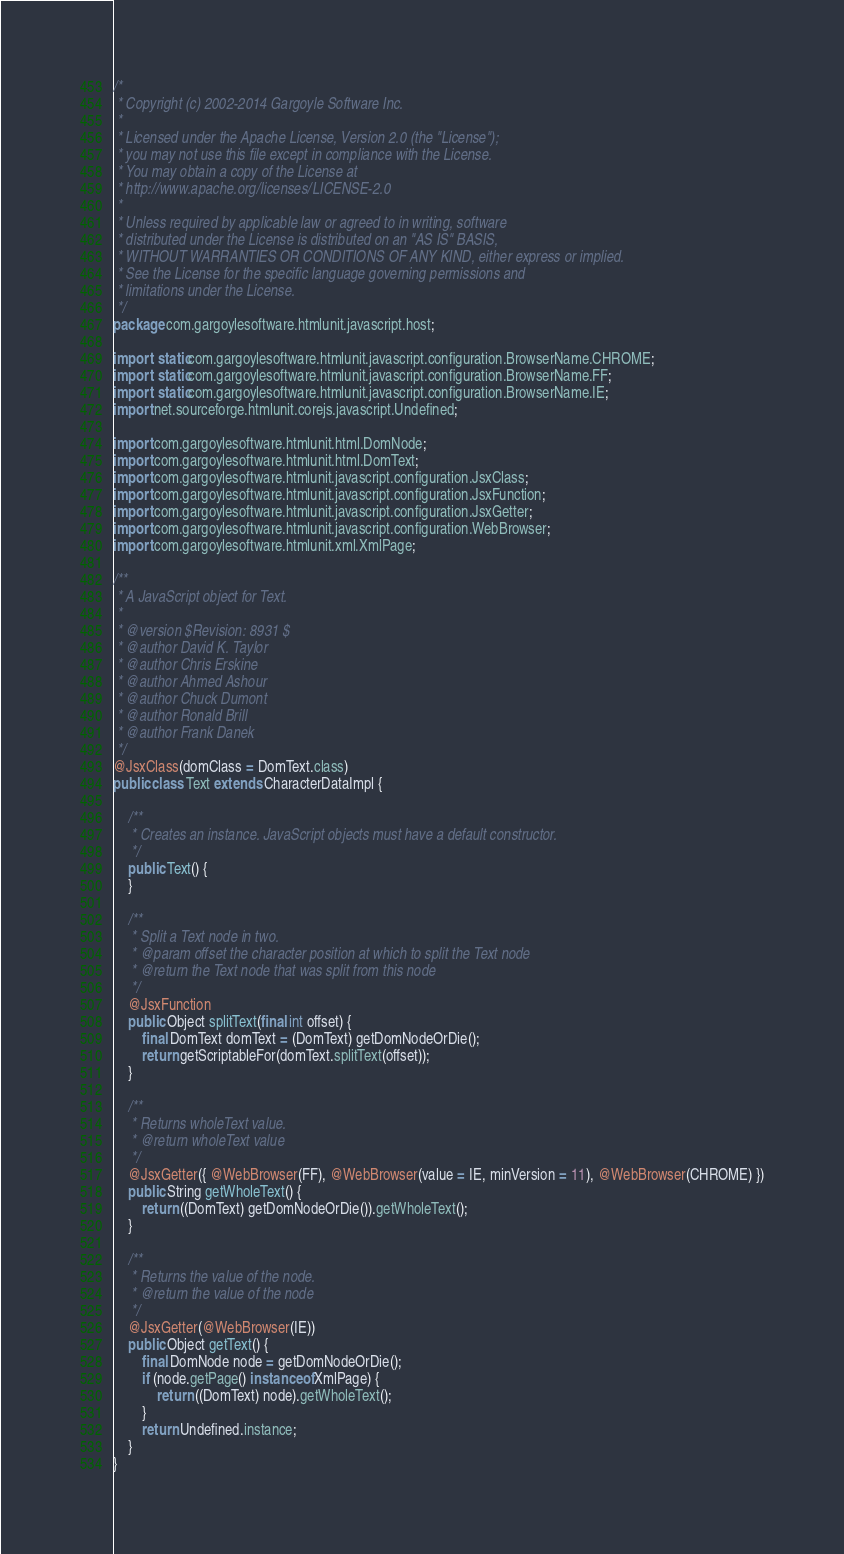Convert code to text. <code><loc_0><loc_0><loc_500><loc_500><_Java_>/*
 * Copyright (c) 2002-2014 Gargoyle Software Inc.
 *
 * Licensed under the Apache License, Version 2.0 (the "License");
 * you may not use this file except in compliance with the License.
 * You may obtain a copy of the License at
 * http://www.apache.org/licenses/LICENSE-2.0
 *
 * Unless required by applicable law or agreed to in writing, software
 * distributed under the License is distributed on an "AS IS" BASIS,
 * WITHOUT WARRANTIES OR CONDITIONS OF ANY KIND, either express or implied.
 * See the License for the specific language governing permissions and
 * limitations under the License.
 */
package com.gargoylesoftware.htmlunit.javascript.host;

import static com.gargoylesoftware.htmlunit.javascript.configuration.BrowserName.CHROME;
import static com.gargoylesoftware.htmlunit.javascript.configuration.BrowserName.FF;
import static com.gargoylesoftware.htmlunit.javascript.configuration.BrowserName.IE;
import net.sourceforge.htmlunit.corejs.javascript.Undefined;

import com.gargoylesoftware.htmlunit.html.DomNode;
import com.gargoylesoftware.htmlunit.html.DomText;
import com.gargoylesoftware.htmlunit.javascript.configuration.JsxClass;
import com.gargoylesoftware.htmlunit.javascript.configuration.JsxFunction;
import com.gargoylesoftware.htmlunit.javascript.configuration.JsxGetter;
import com.gargoylesoftware.htmlunit.javascript.configuration.WebBrowser;
import com.gargoylesoftware.htmlunit.xml.XmlPage;

/**
 * A JavaScript object for Text.
 *
 * @version $Revision: 8931 $
 * @author David K. Taylor
 * @author Chris Erskine
 * @author Ahmed Ashour
 * @author Chuck Dumont
 * @author Ronald Brill
 * @author Frank Danek
 */
@JsxClass(domClass = DomText.class)
public class Text extends CharacterDataImpl {

    /**
     * Creates an instance. JavaScript objects must have a default constructor.
     */
    public Text() {
    }

    /**
     * Split a Text node in two.
     * @param offset the character position at which to split the Text node
     * @return the Text node that was split from this node
     */
    @JsxFunction
    public Object splitText(final int offset) {
        final DomText domText = (DomText) getDomNodeOrDie();
        return getScriptableFor(domText.splitText(offset));
    }

    /**
     * Returns wholeText value.
     * @return wholeText value
     */
    @JsxGetter({ @WebBrowser(FF), @WebBrowser(value = IE, minVersion = 11), @WebBrowser(CHROME) })
    public String getWholeText() {
        return ((DomText) getDomNodeOrDie()).getWholeText();
    }

    /**
     * Returns the value of the node.
     * @return the value of the node
     */
    @JsxGetter(@WebBrowser(IE))
    public Object getText() {
        final DomNode node = getDomNodeOrDie();
        if (node.getPage() instanceof XmlPage) {
            return ((DomText) node).getWholeText();
        }
        return Undefined.instance;
    }
}
</code> 